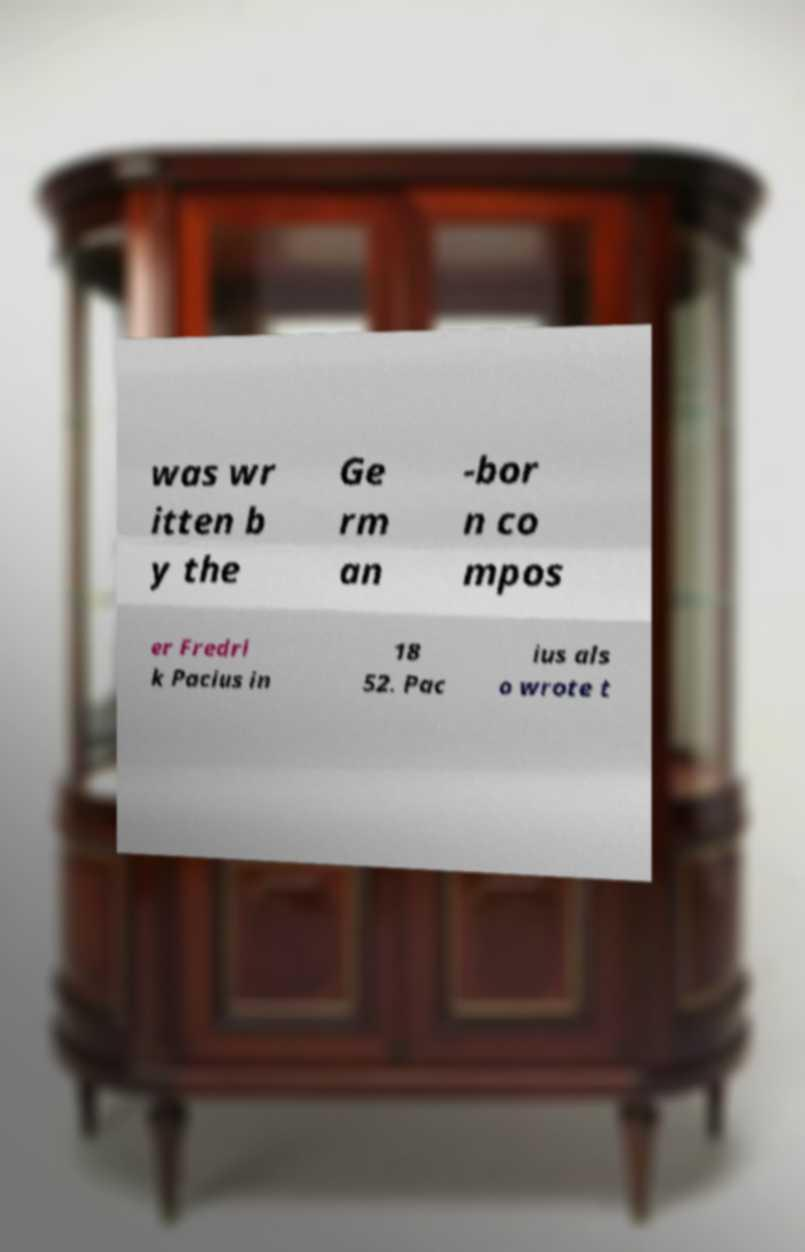Please identify and transcribe the text found in this image. was wr itten b y the Ge rm an -bor n co mpos er Fredri k Pacius in 18 52. Pac ius als o wrote t 